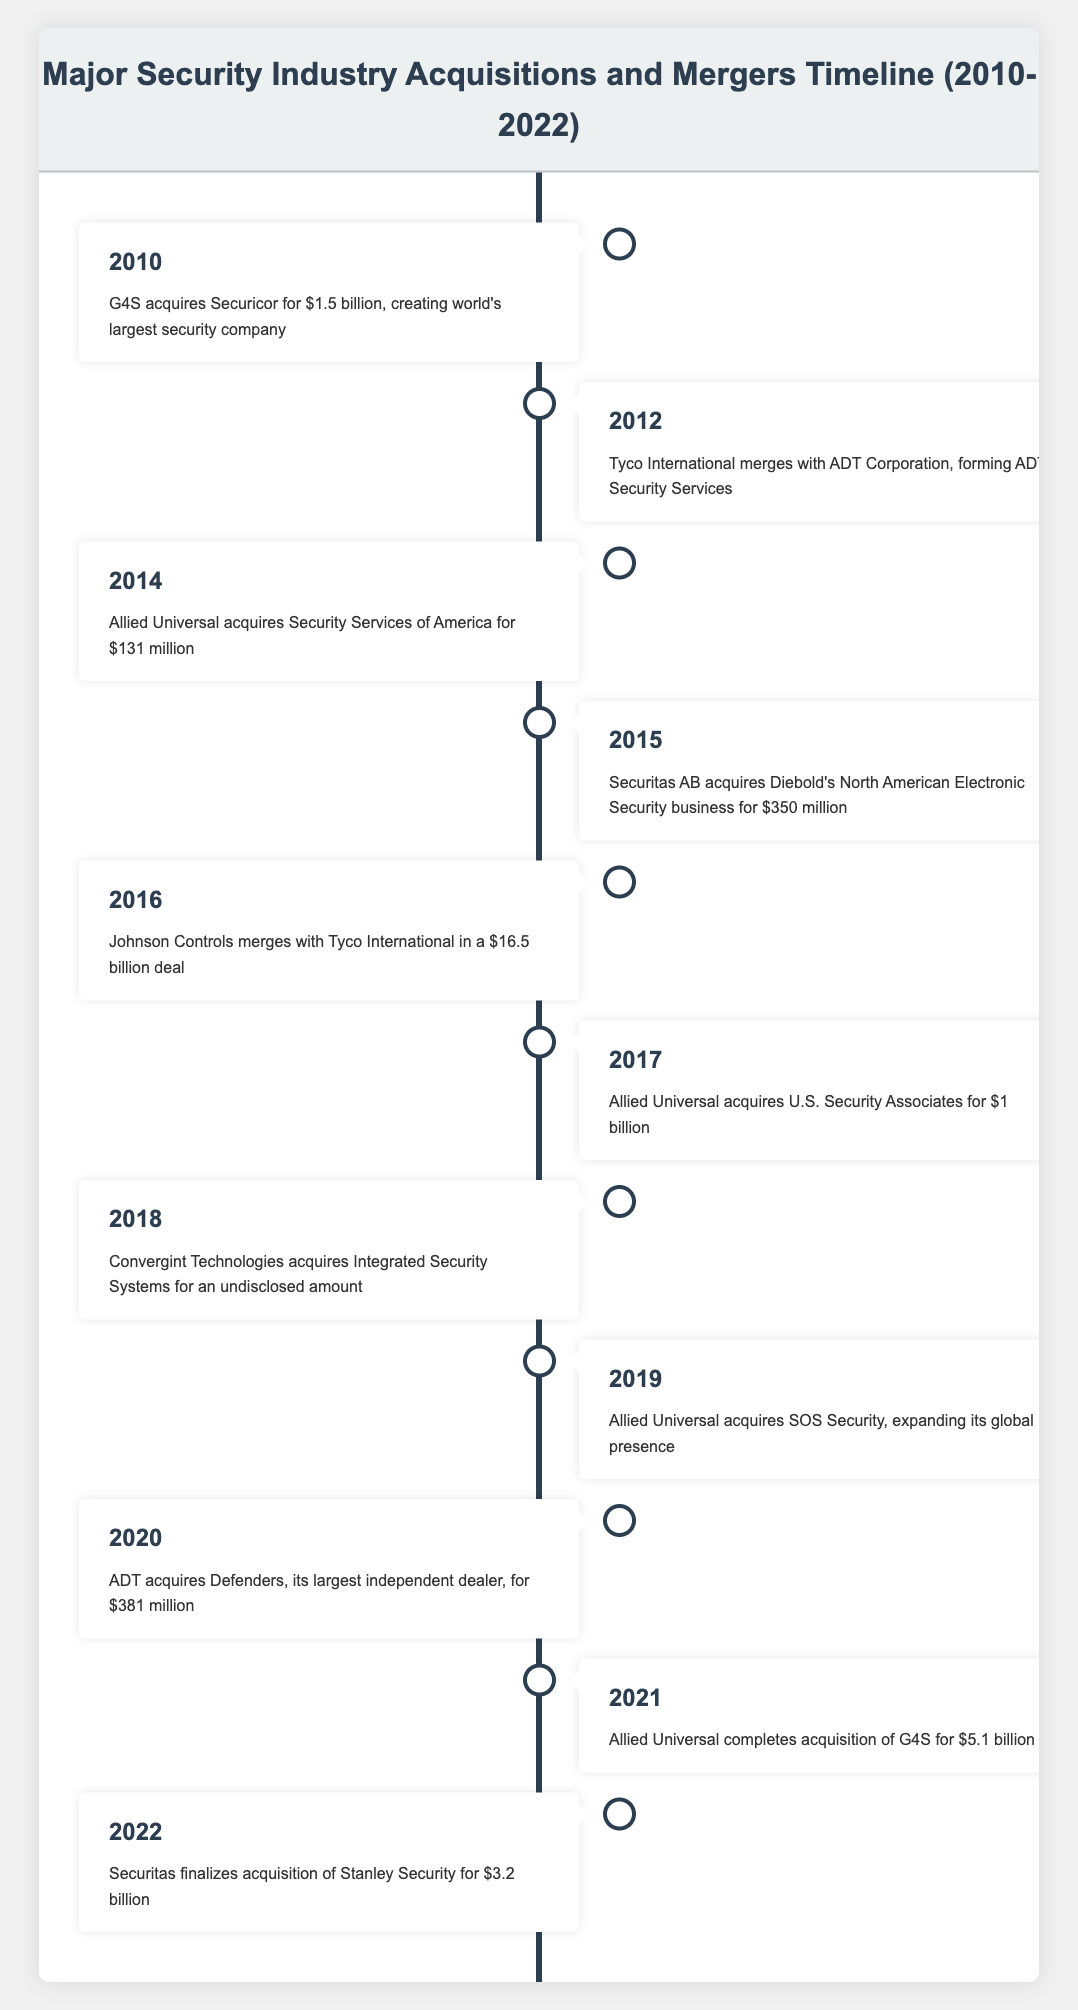What was the significant acquisition made by G4S in 2010? In 2010, G4S acquired Securicor for $1.5 billion, which was noted as creating the world's largest security company.
Answer: G4S acquires Securicor for $1.5 billion Which company merged with ADT Corporation in 2012? According to the timeline, Tyco International merged with ADT Corporation in 2012, forming ADT Security Services.
Answer: Tyco International What was the total value of acquisitions by Allied Universal in 2017 and 2021 combined? In 2017, Allied Universal acquired U.S. Security Associates for $1 billion and completed acquisition of G4S for $5.1 billion in 2021. Adding these values together gives $1 billion + $5.1 billion = $6.1 billion.
Answer: $6.1 billion Did Securitas make any acquisitions in 2015? Yes, in 2015, Securitas AB acquired Diebold's North American Electronic Security business for $350 million.
Answer: Yes Was there an acquisition by ADT in 2020? Yes, ADT acquired Defenders for $381 million in 2020, which is mentioned in the timeline.
Answer: Yes What is the total number of acquisitions made by Allied Universal from 2014 to 2021? Between 2014 and 2021, Allied Universal made a total of four acquisitions: Security Services of America (2014), U.S. Security Associates (2017), SOS Security (2019), and G4S (2021), which totals to 4 acquisitions.
Answer: 4 acquisitions Which acquisition had the highest value in the timeline and what was the amount? The acquisition with the highest value in the timeline is Allied Universal's acquisition of G4S in 2021 for $5.1 billion.
Answer: $5.1 billion Was there any acquisition that occurred in 2018? Yes, Convergint Technologies acquired Integrated Security Systems in 2018, though the amount was undisclosed.
Answer: Yes Which year saw the least amount of acquisition value mentioned in the timeline? In 2014, Allied Universal acquired Security Services of America for $131 million, which is the least amount mentioned among the acquisitions.
Answer: 2014 